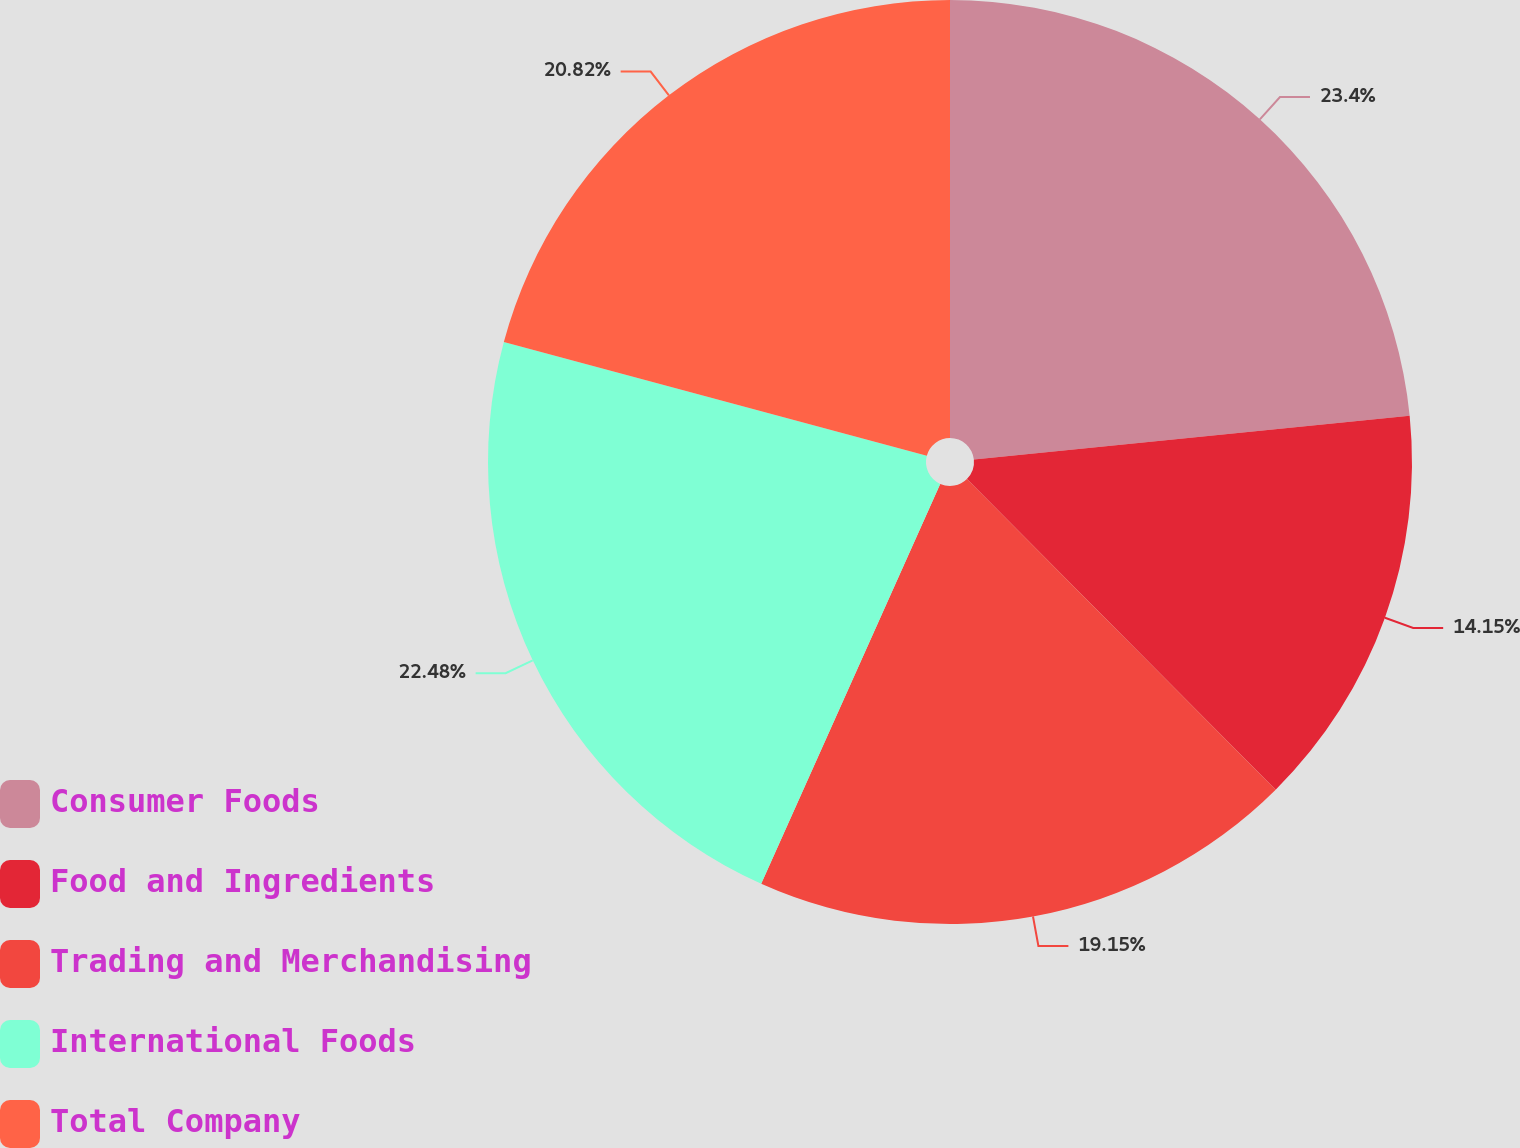Convert chart to OTSL. <chart><loc_0><loc_0><loc_500><loc_500><pie_chart><fcel>Consumer Foods<fcel>Food and Ingredients<fcel>Trading and Merchandising<fcel>International Foods<fcel>Total Company<nl><fcel>23.4%<fcel>14.15%<fcel>19.15%<fcel>22.48%<fcel>20.82%<nl></chart> 